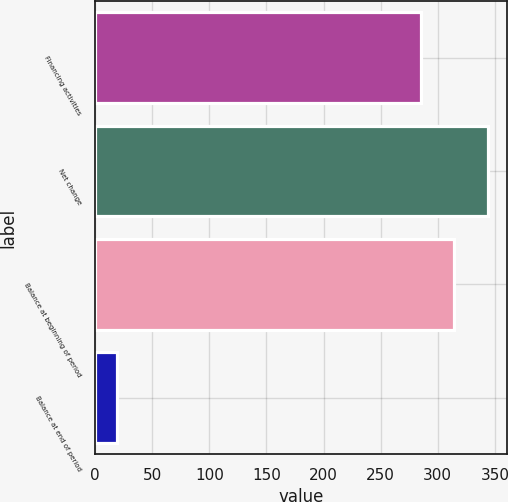Convert chart to OTSL. <chart><loc_0><loc_0><loc_500><loc_500><bar_chart><fcel>Financing activities<fcel>Net change<fcel>Balance at beginning of period<fcel>Balance at end of period<nl><fcel>285<fcel>343.8<fcel>314.4<fcel>19<nl></chart> 